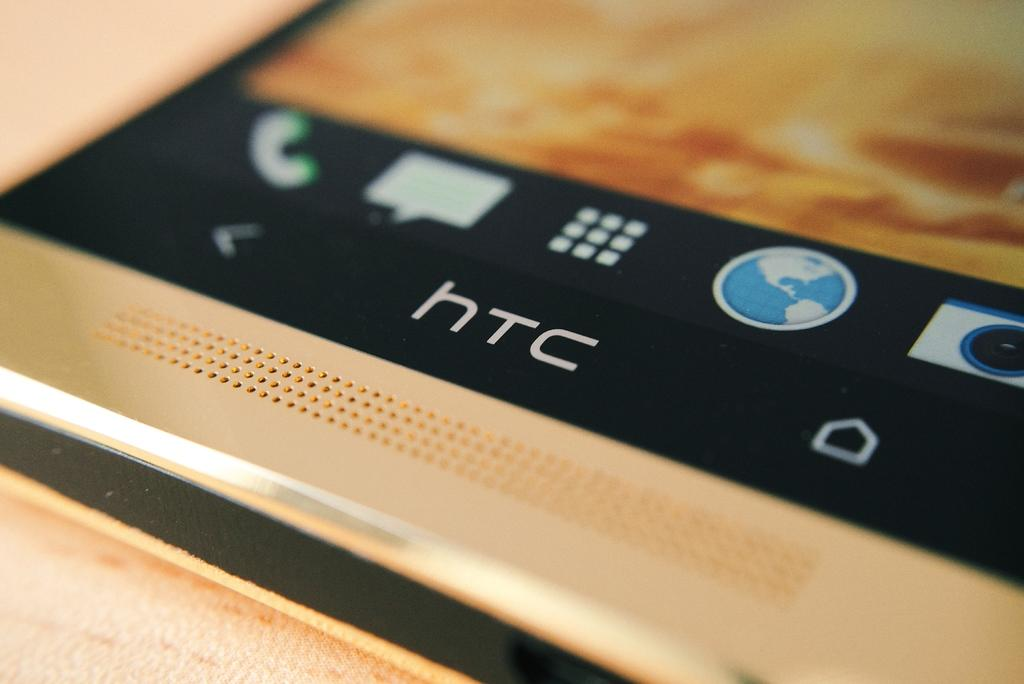<image>
Describe the image concisely. a close up of an HTC branded cell phone 